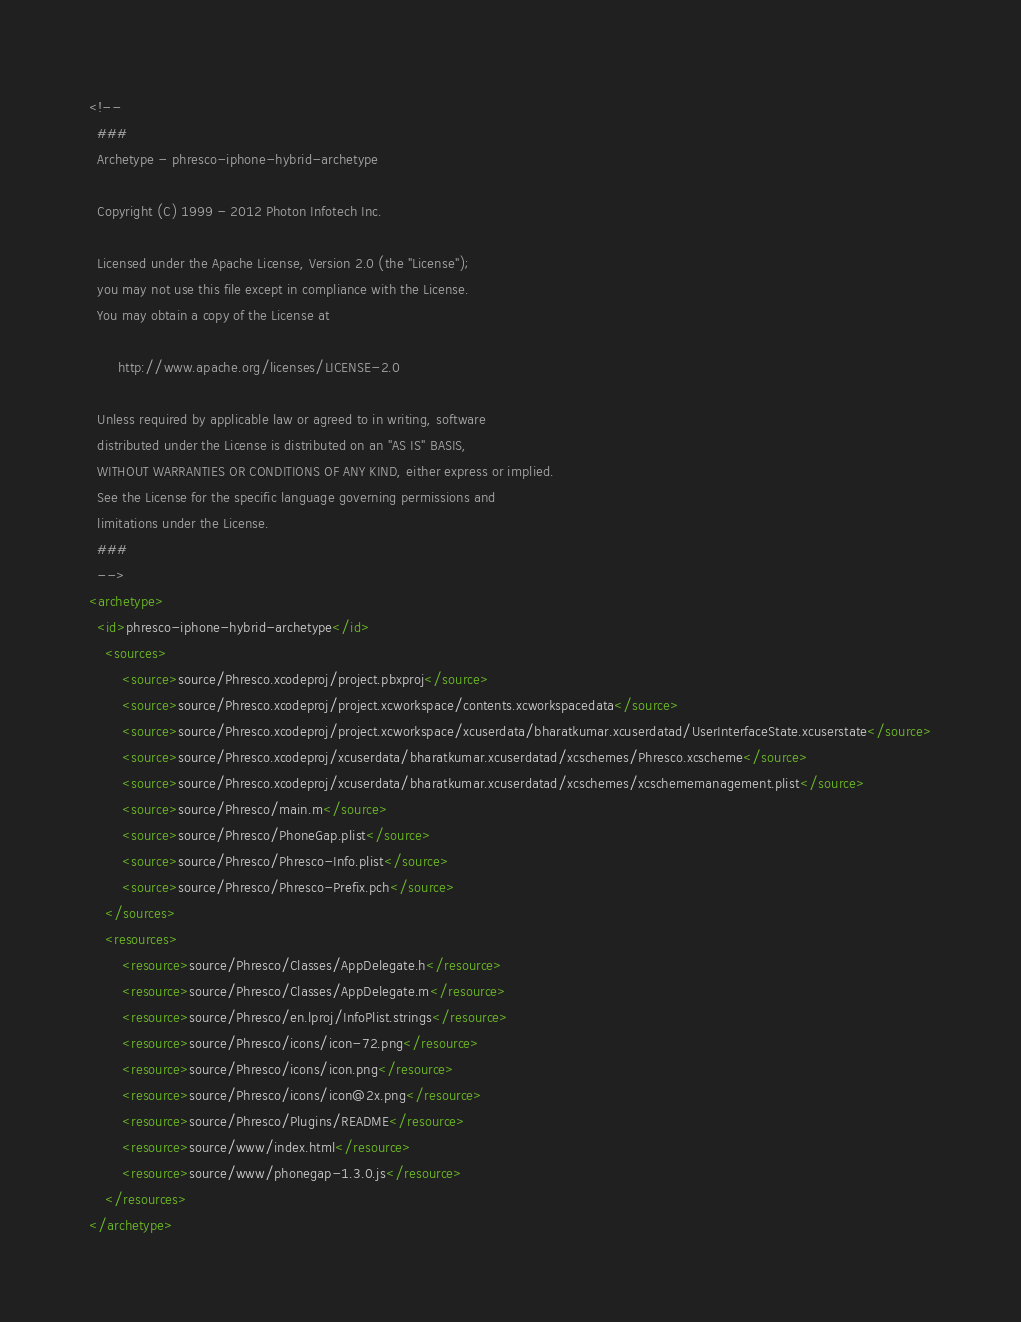Convert code to text. <code><loc_0><loc_0><loc_500><loc_500><_XML_><!--
  ###
  Archetype - phresco-iphone-hybrid-archetype
  
  Copyright (C) 1999 - 2012 Photon Infotech Inc.
  
  Licensed under the Apache License, Version 2.0 (the "License");
  you may not use this file except in compliance with the License.
  You may obtain a copy of the License at
  
       http://www.apache.org/licenses/LICENSE-2.0
  
  Unless required by applicable law or agreed to in writing, software
  distributed under the License is distributed on an "AS IS" BASIS,
  WITHOUT WARRANTIES OR CONDITIONS OF ANY KIND, either express or implied.
  See the License for the specific language governing permissions and
  limitations under the License.
  ###
  -->
<archetype>
  <id>phresco-iphone-hybrid-archetype</id>
	<sources>
		<source>source/Phresco.xcodeproj/project.pbxproj</source>
		<source>source/Phresco.xcodeproj/project.xcworkspace/contents.xcworkspacedata</source>
		<source>source/Phresco.xcodeproj/project.xcworkspace/xcuserdata/bharatkumar.xcuserdatad/UserInterfaceState.xcuserstate</source>
		<source>source/Phresco.xcodeproj/xcuserdata/bharatkumar.xcuserdatad/xcschemes/Phresco.xcscheme</source>
		<source>source/Phresco.xcodeproj/xcuserdata/bharatkumar.xcuserdatad/xcschemes/xcschememanagement.plist</source>
		<source>source/Phresco/main.m</source>
		<source>source/Phresco/PhoneGap.plist</source>
		<source>source/Phresco/Phresco-Info.plist</source>
		<source>source/Phresco/Phresco-Prefix.pch</source>
	</sources>
	<resources>
		<resource>source/Phresco/Classes/AppDelegate.h</resource>
		<resource>source/Phresco/Classes/AppDelegate.m</resource>
		<resource>source/Phresco/en.lproj/InfoPlist.strings</resource>
		<resource>source/Phresco/icons/icon-72.png</resource>
		<resource>source/Phresco/icons/icon.png</resource>
		<resource>source/Phresco/icons/icon@2x.png</resource>
		<resource>source/Phresco/Plugins/README</resource>
		<resource>source/www/index.html</resource>
		<resource>source/www/phonegap-1.3.0.js</resource>
	</resources>
</archetype>
</code> 